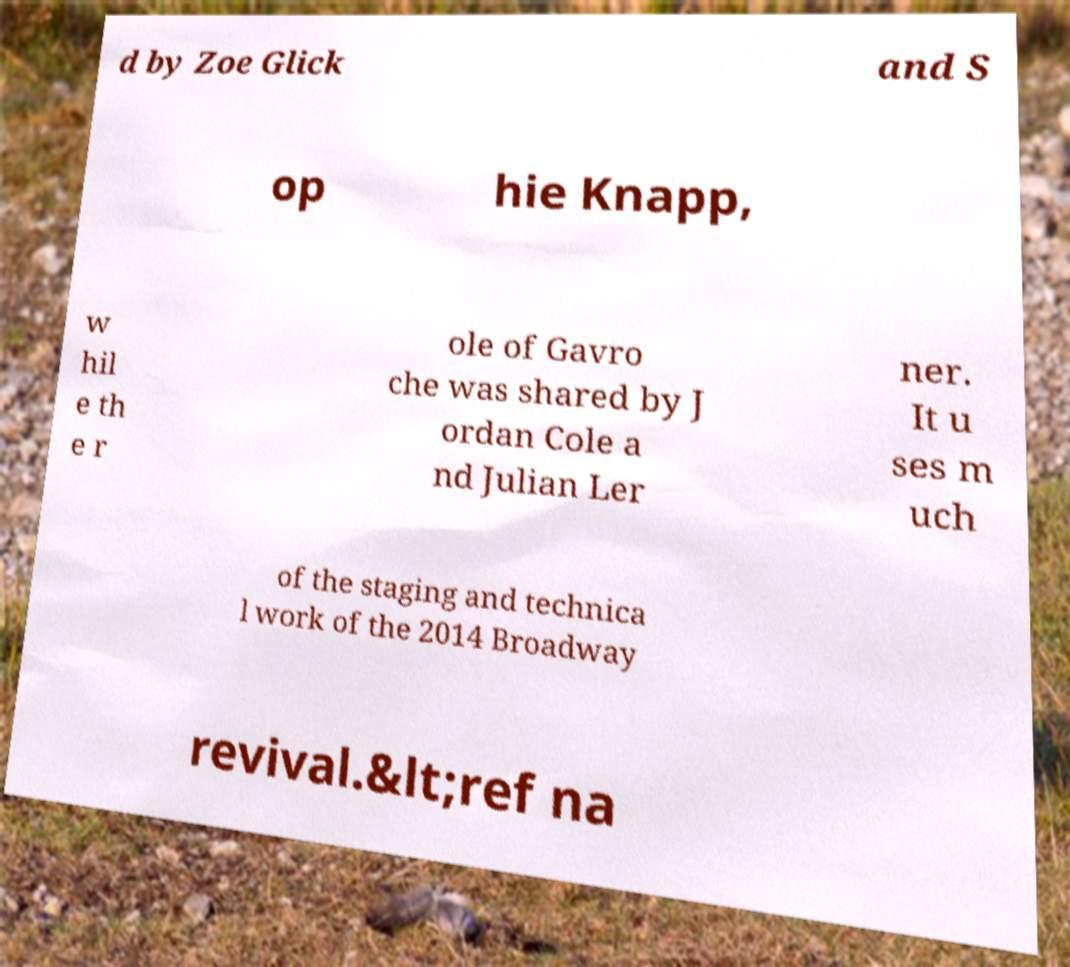Can you read and provide the text displayed in the image?This photo seems to have some interesting text. Can you extract and type it out for me? d by Zoe Glick and S op hie Knapp, w hil e th e r ole of Gavro che was shared by J ordan Cole a nd Julian Ler ner. It u ses m uch of the staging and technica l work of the 2014 Broadway revival.&lt;ref na 